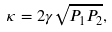Convert formula to latex. <formula><loc_0><loc_0><loc_500><loc_500>\kappa = 2 \gamma \sqrt { P _ { 1 } P _ { 2 } } ,</formula> 